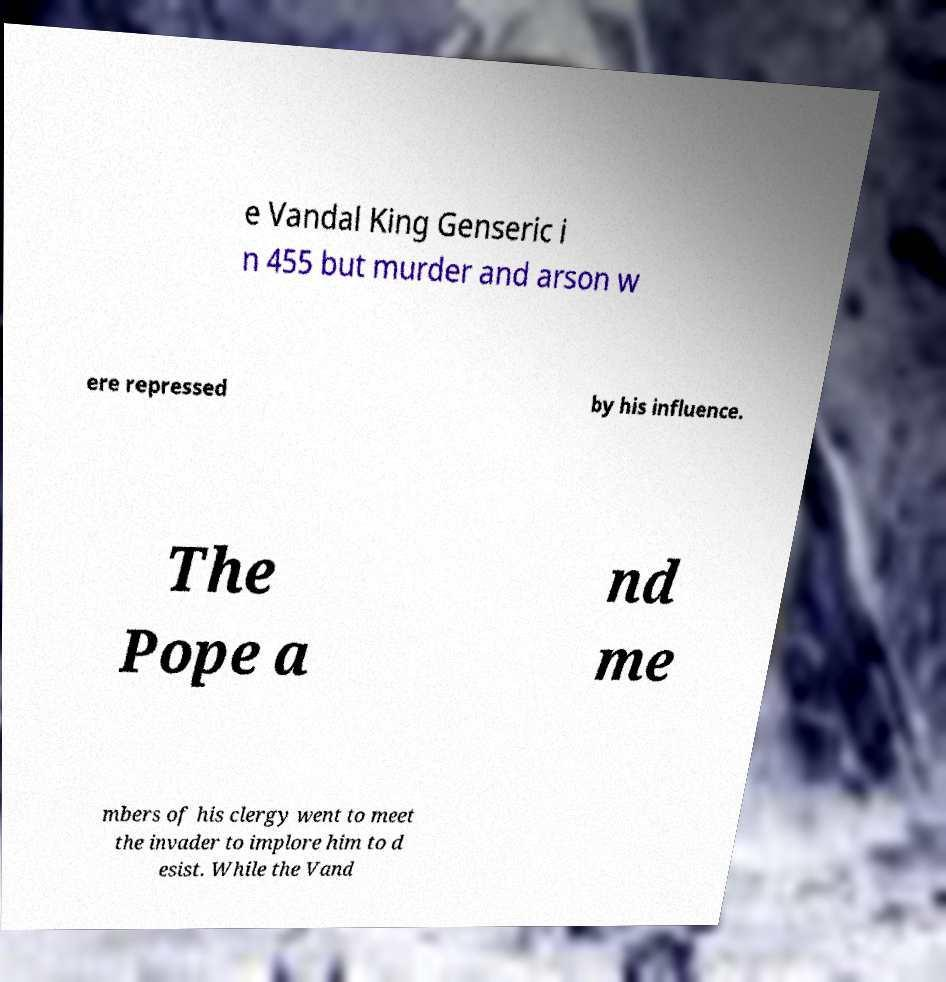Please read and relay the text visible in this image. What does it say? e Vandal King Genseric i n 455 but murder and arson w ere repressed by his influence. The Pope a nd me mbers of his clergy went to meet the invader to implore him to d esist. While the Vand 